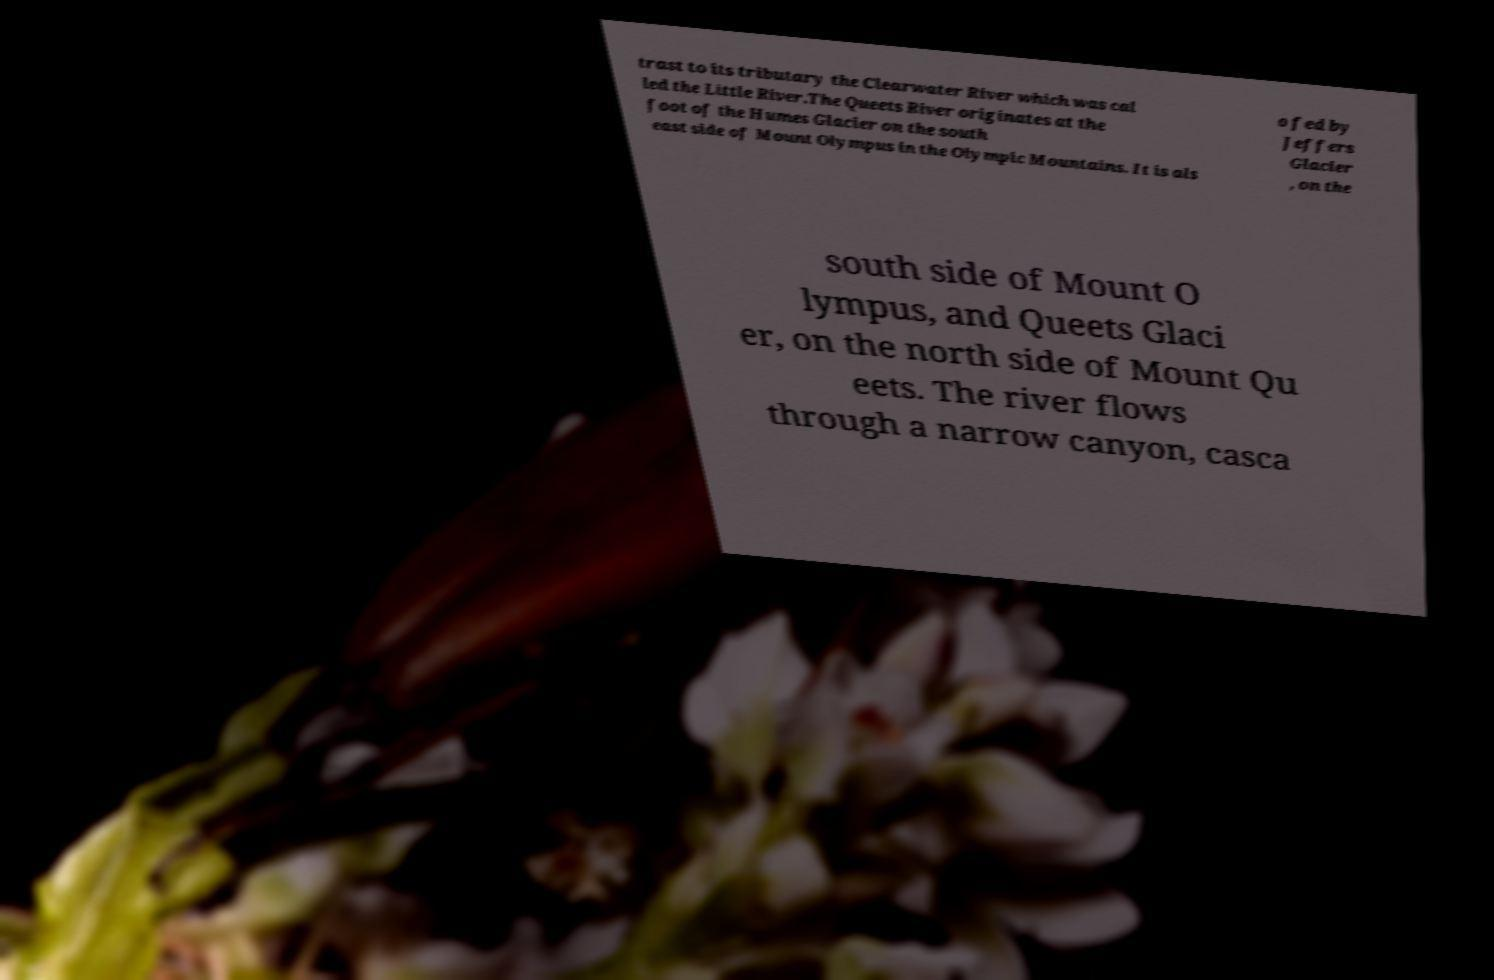I need the written content from this picture converted into text. Can you do that? trast to its tributary the Clearwater River which was cal led the Little River.The Queets River originates at the foot of the Humes Glacier on the south east side of Mount Olympus in the Olympic Mountains. It is als o fed by Jeffers Glacier , on the south side of Mount O lympus, and Queets Glaci er, on the north side of Mount Qu eets. The river flows through a narrow canyon, casca 